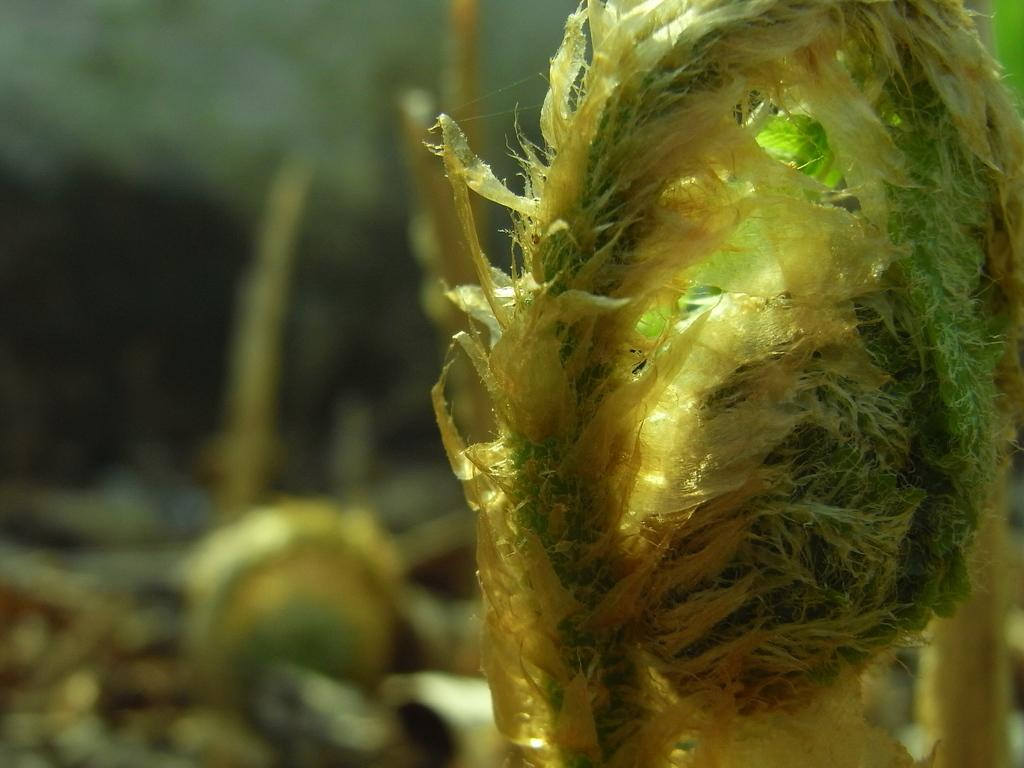What type of plants are in the image? There are water plants in the image. Where are the water plants located? The water plants are in the water. What disease is being treated by the water plants in the image? There is no indication in the image that the water plants are being used to treat any disease. 